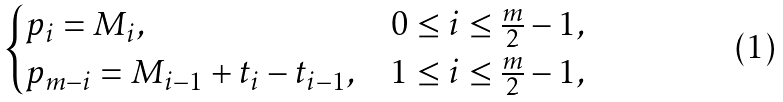<formula> <loc_0><loc_0><loc_500><loc_500>\begin{cases} p _ { i } = M _ { i } , & 0 \leq i \leq \frac { m } { 2 } - 1 , \\ p _ { m - i } = M _ { i - 1 } + t _ { i } - t _ { i - 1 } , & 1 \leq i \leq \frac { m } { 2 } - 1 , \end{cases}</formula> 